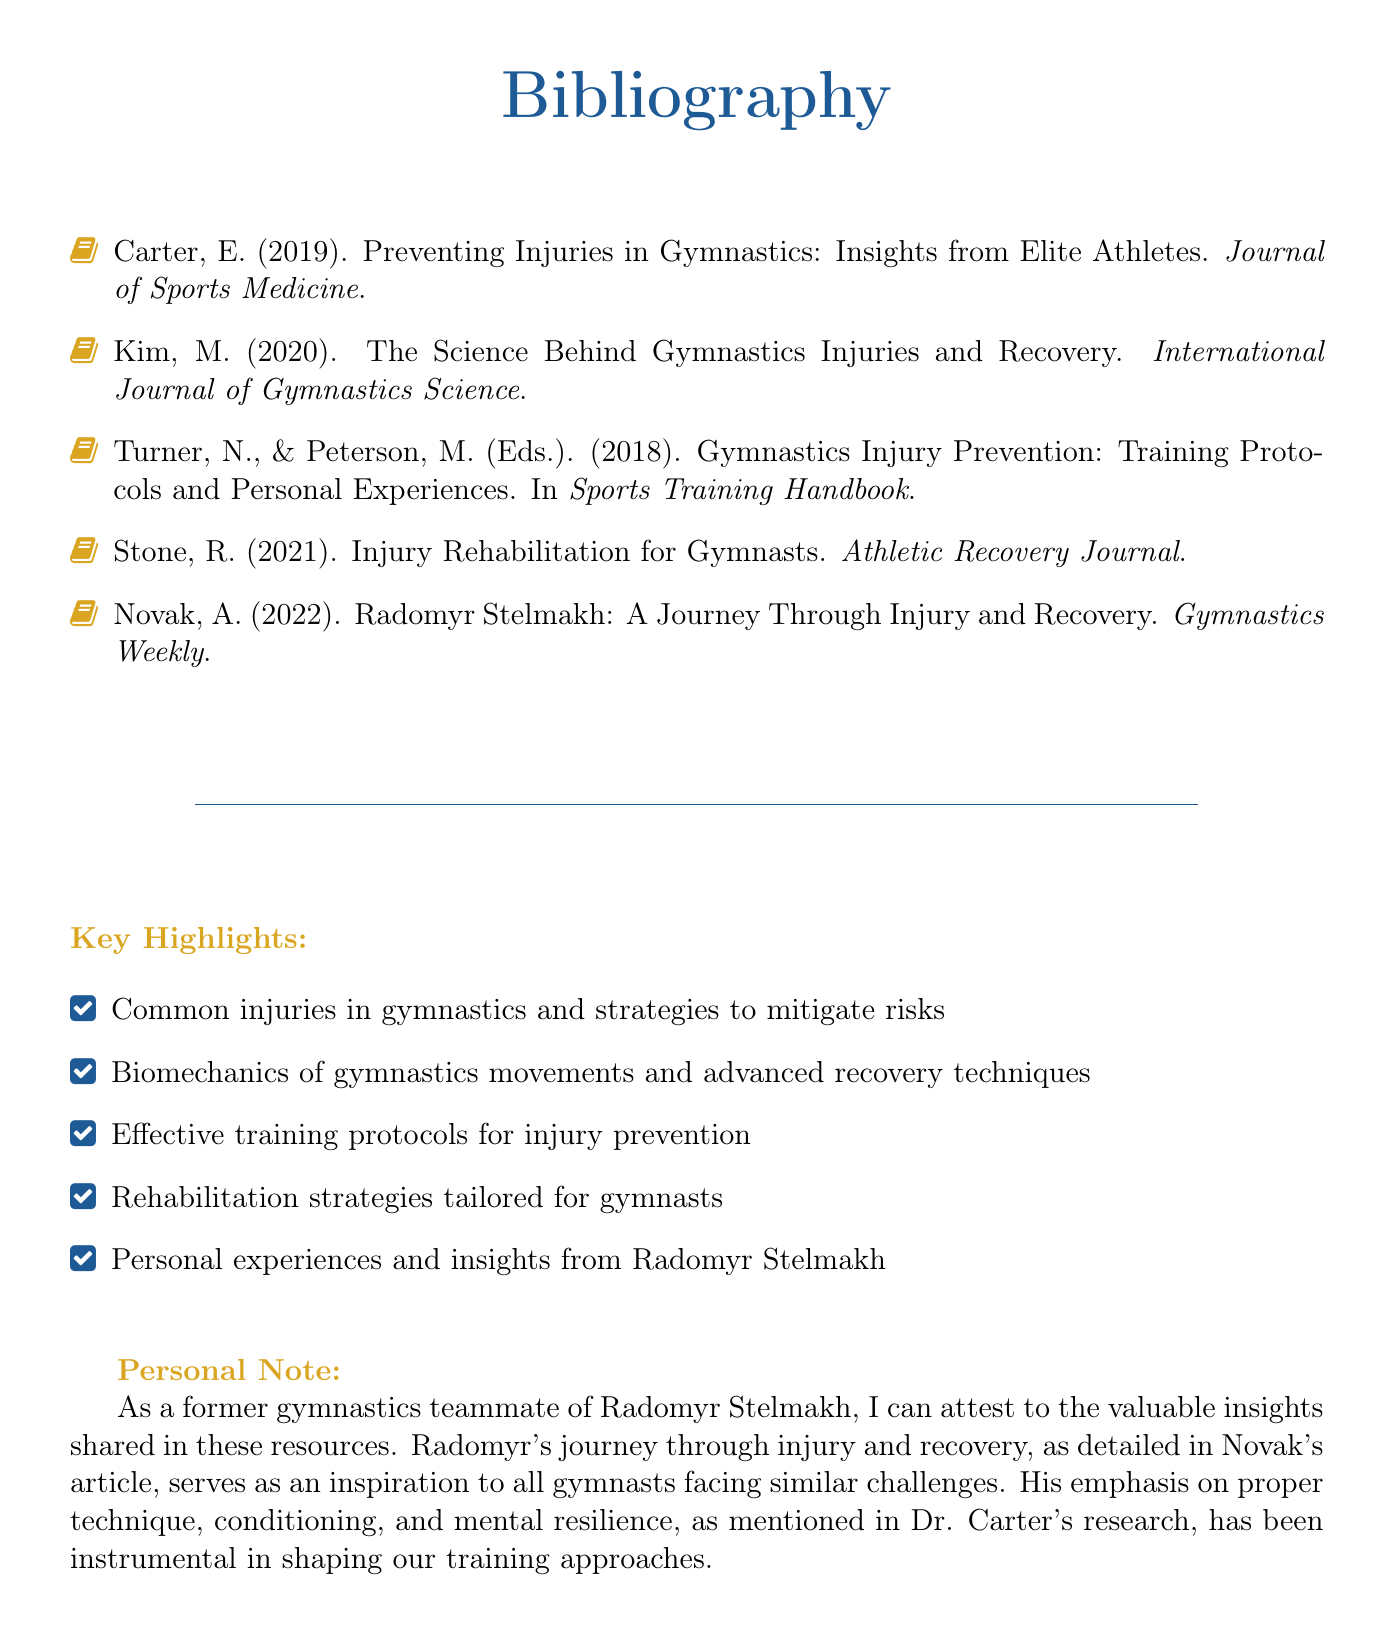What is the title of the document? The title of the document is presented in the center at the beginning and defines the content focus, which is "Bibliography."
Answer: Bibliography Who is the author of the article published in 2019? The bibliography lists specific articles along with their authors, indicating that E. Carter authored the 2019 article.
Answer: E. Carter What year was Radomyr Stelmakh's journey through injury and recovery published? The year of publication is provided in the last entry of the bibliography, referencing 2022.
Answer: 2022 What common theme is highlighted in the key highlights section? The key highlights summarize the document's focus, indicating injury prevention in gymnastics as a particularly evident theme.
Answer: Injury prevention Which publication discusses effective training protocols? By examining the bibliography, one can note that the publication edited by Turner and Peterson addresses training protocols.
Answer: Sports Training Handbook How many articles are listed in the bibliography? The total count of entries can be tallied, showcasing a total of five articles present in the bibliography.
Answer: Five What does Radomyr Stelmakh's personal note emphasize? The personal note reflects Radomyr's insights on specific aspects relevant to gymnastics, such as technique and mental resilience.
Answer: Technique, conditioning, and mental resilience From which type of journal is the 2021 article about injury rehabilitation? By reviewing the bibliographic entries, one can find that the 2021 article is from the "Athletic Recovery Journal."
Answer: Athletic Recovery Journal What is the color associated with the section titles in the document? The section titles are formatted with a specific color defined in the document, identified as "gymnast."
Answer: Gymnast 